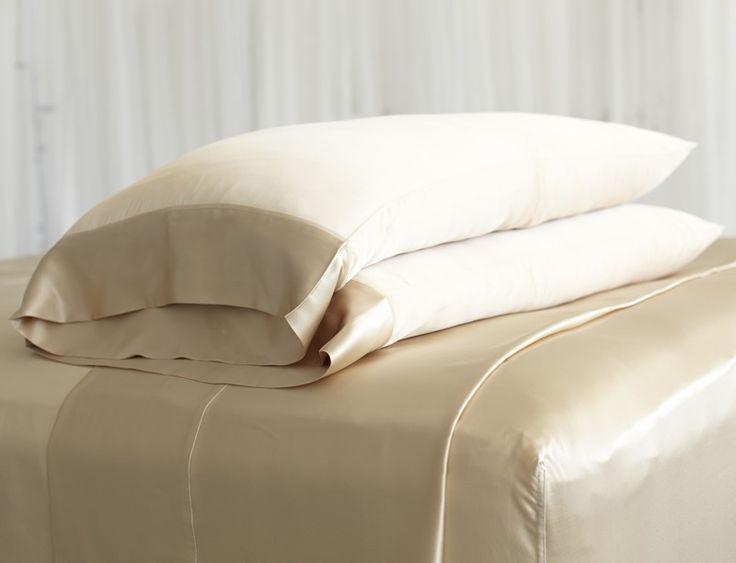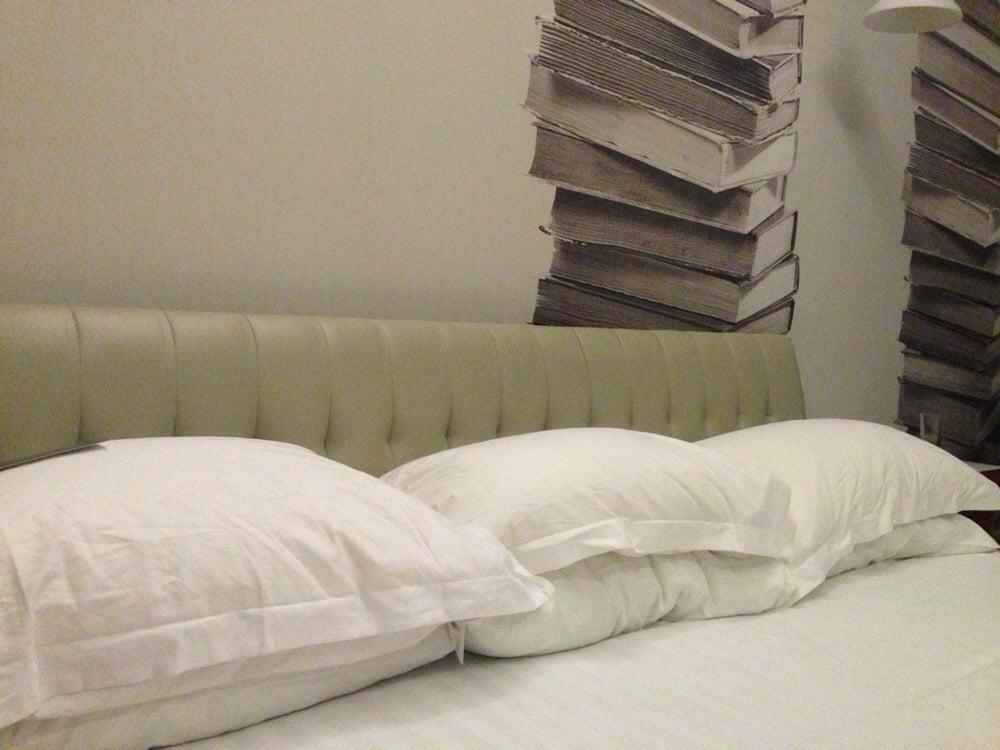The first image is the image on the left, the second image is the image on the right. Evaluate the accuracy of this statement regarding the images: "An image shows pillows in front of a non-tufted headboard.". Is it true? Answer yes or no. No. The first image is the image on the left, the second image is the image on the right. Given the left and right images, does the statement "A window near the bed is letting in natural light." hold true? Answer yes or no. No. 